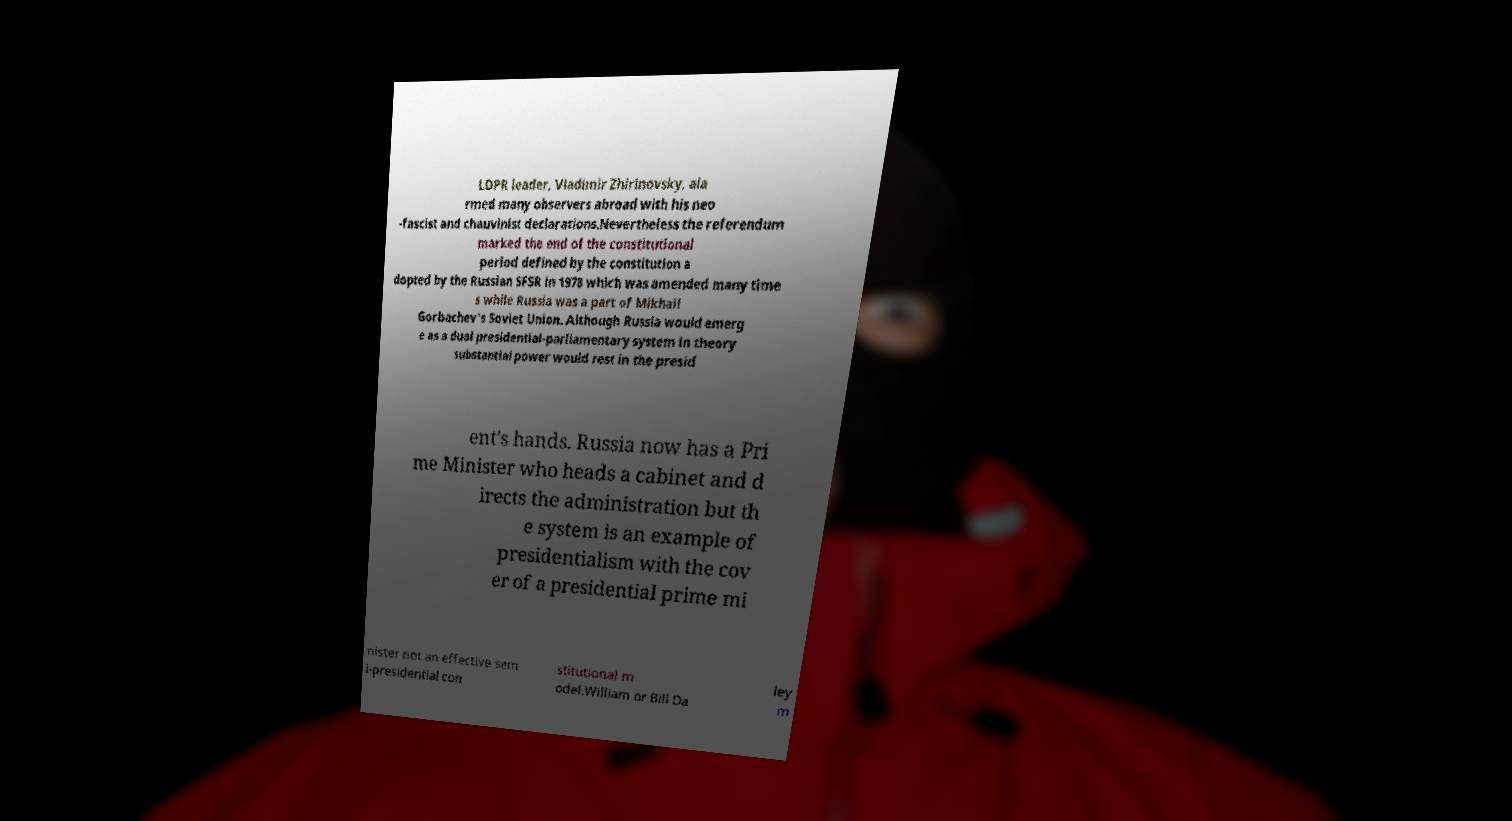What messages or text are displayed in this image? I need them in a readable, typed format. LDPR leader, Vladimir Zhirinovsky, ala rmed many observers abroad with his neo -fascist and chauvinist declarations.Nevertheless the referendum marked the end of the constitutional period defined by the constitution a dopted by the Russian SFSR in 1978 which was amended many time s while Russia was a part of Mikhail Gorbachev's Soviet Union. Although Russia would emerg e as a dual presidential-parliamentary system in theory substantial power would rest in the presid ent's hands. Russia now has a Pri me Minister who heads a cabinet and d irects the administration but th e system is an example of presidentialism with the cov er of a presidential prime mi nister not an effective sem i-presidential con stitutional m odel.William or Bill Da ley m 